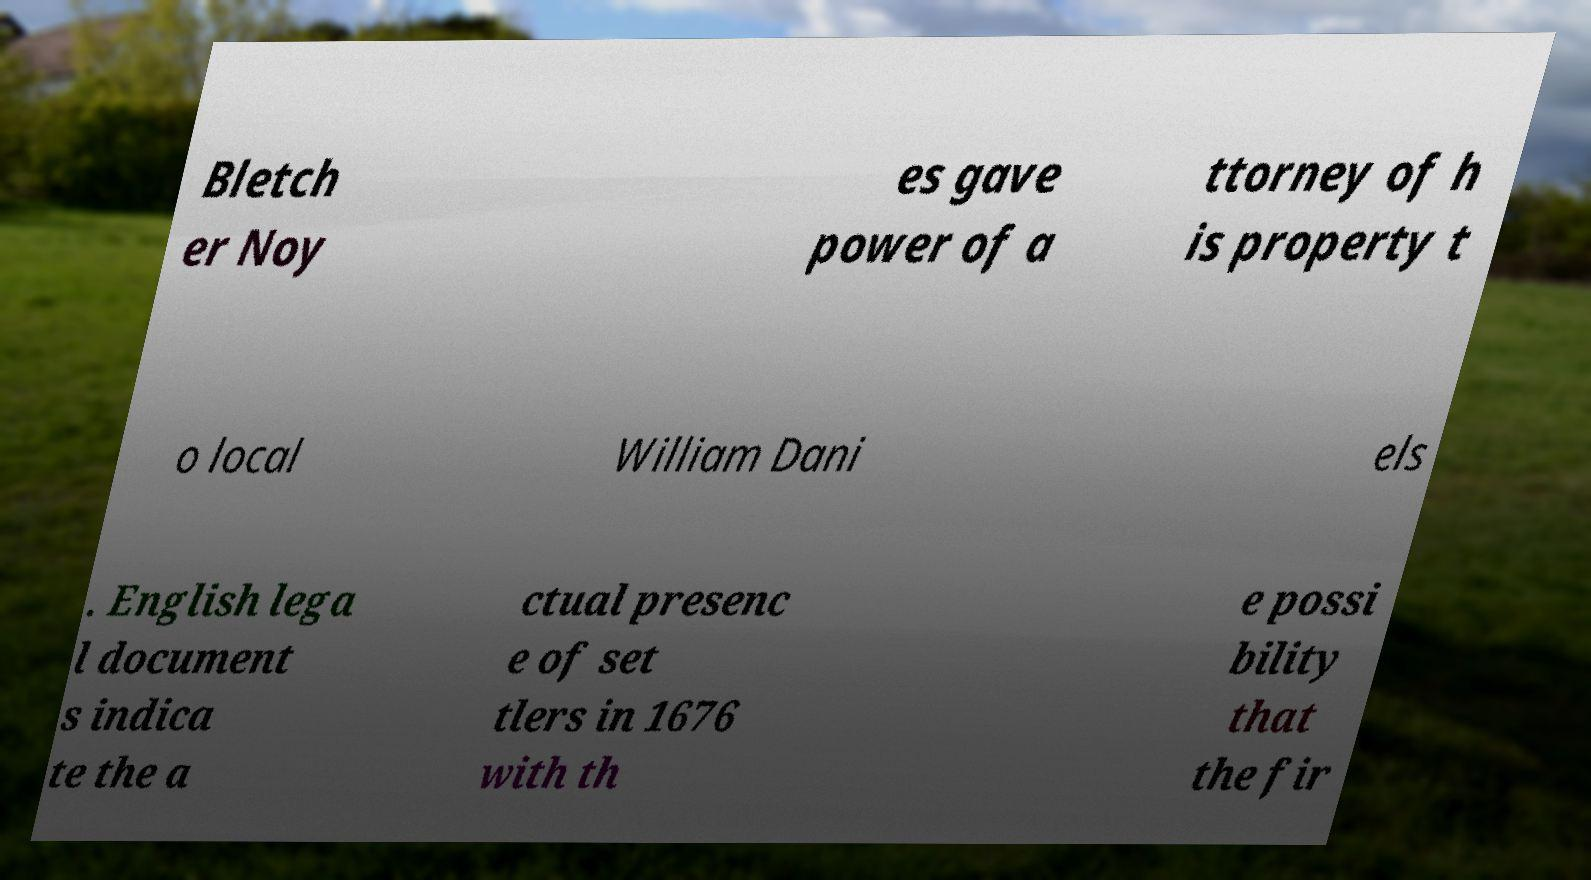Could you extract and type out the text from this image? Bletch er Noy es gave power of a ttorney of h is property t o local William Dani els . English lega l document s indica te the a ctual presenc e of set tlers in 1676 with th e possi bility that the fir 